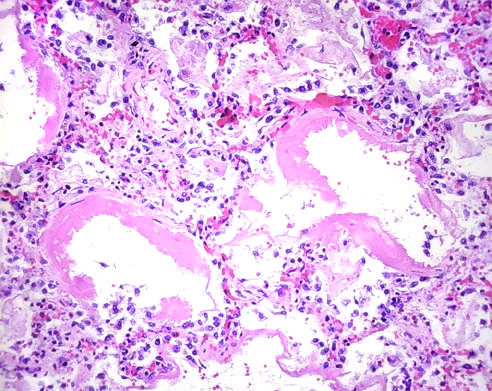what are collapsed, while others are distended?
Answer the question using a single word or phrase. Some alveoli 